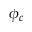<formula> <loc_0><loc_0><loc_500><loc_500>\phi _ { c }</formula> 